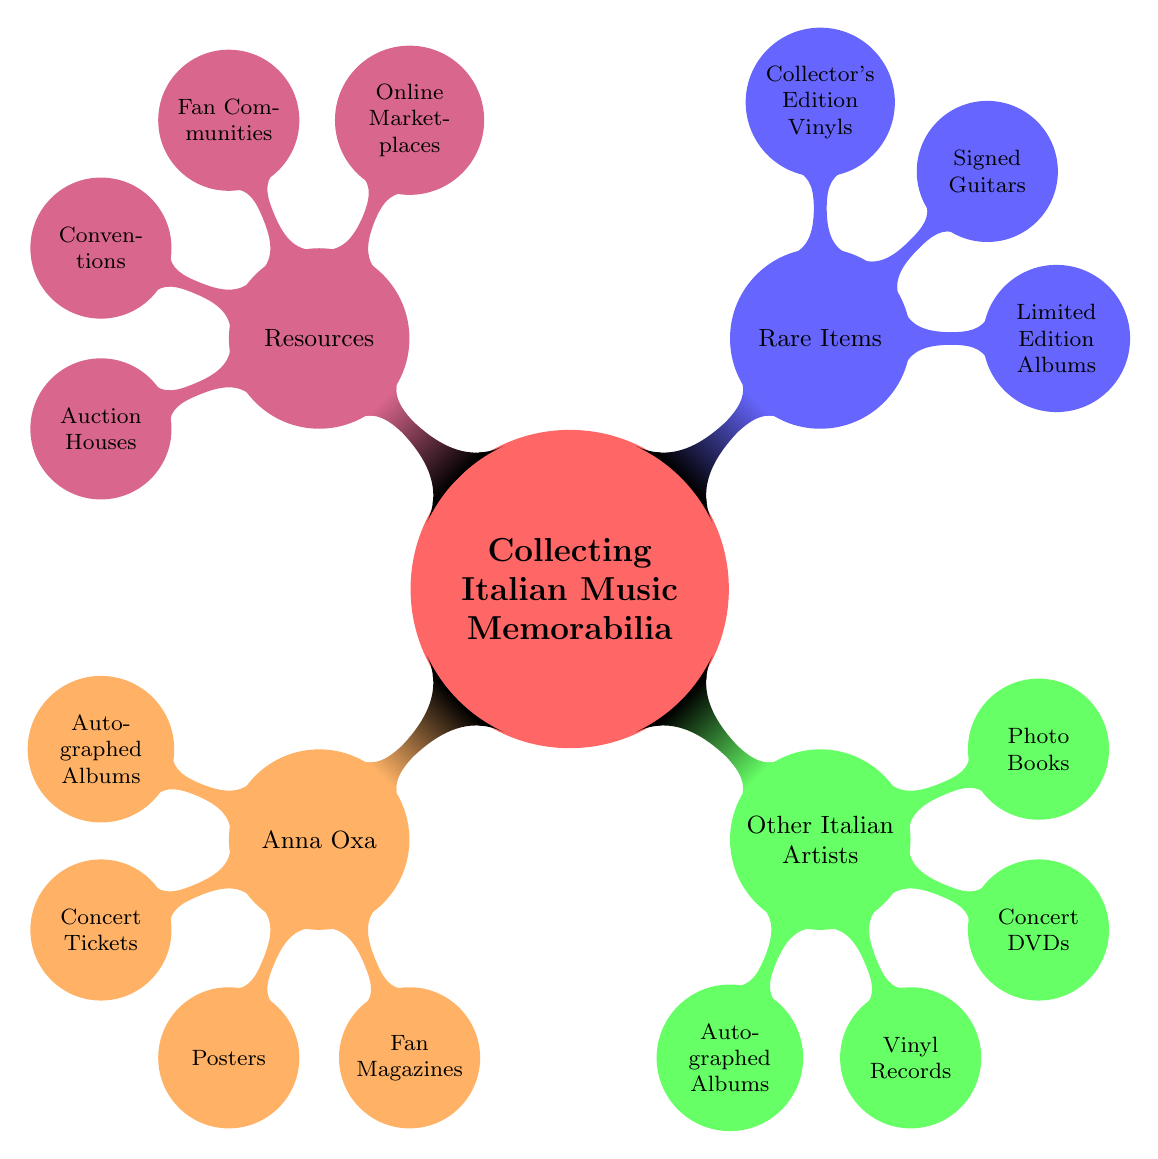What are the two categories of memorabilia related to Anna Oxa? The main categories of memorabilia related to Anna Oxa listed in the diagram are "Autographed Albums" and "Concert Tickets". These are the first items under her section.
Answer: Autographed Albums, Concert Tickets How many nodes are there under "Resources"? The "Resources" node has four child nodes: "Online Marketplaces", "Fan Communities", "Conventions", and "Auction Houses". Therefore, the total number of nodes under "Resources" is four.
Answer: 4 Which other artist's autographed album is listed besides Anna Oxa? The diagram shows two autographed albums under "Other Italian Artists," one of which is "Eros Ramazzotti - Musica è". This indicates that there are other artists with autographed albums.
Answer: Eros Ramazzotti - Musica è What is the common type of item listed under both Anna Oxa and Other Italian Artists? Both categories have "Autographed Albums" as a common type of memorabilia, highlighting that it is a popular item among collectors within Italian music memorabilia.
Answer: Autographed Albums Which artist is associated with the signed guitar "Ligabue's Gibson"? The signed guitar "Ligabue's Gibson" is mentioned under the "Rare Items" category. This indicates that Ligabue is the associated artist for this particular memorabilia.
Answer: Ligabue 